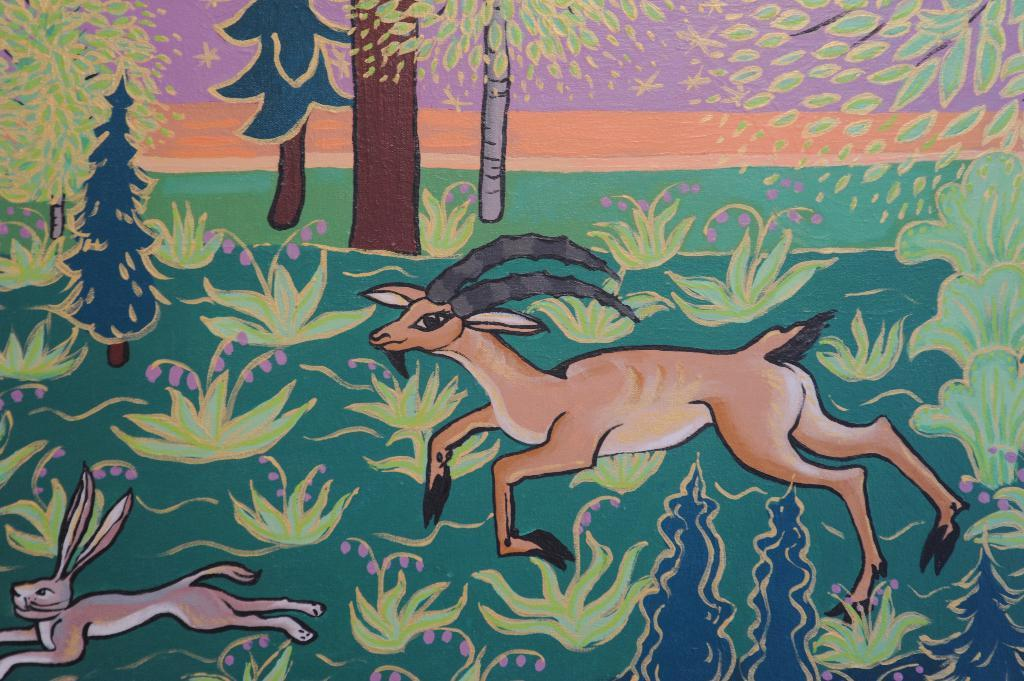What is the main subject of the painting in the image? The painting depicts a rabbit and a deer. What are the animals in the painting doing? The rabbit and deer are running on the grass in the painting. What type of vegetation is visible in the painting? There are trees beside the painting. How many rings can be seen on the rabbit's ears in the image? There are no rings visible on the rabbit's ears in the image, as the painting depicts the animals in a natural setting without any accessories. 